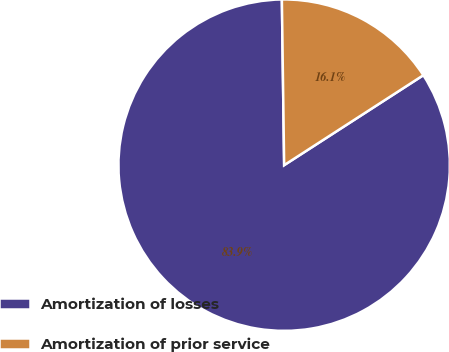Convert chart to OTSL. <chart><loc_0><loc_0><loc_500><loc_500><pie_chart><fcel>Amortization of losses<fcel>Amortization of prior service<nl><fcel>83.91%<fcel>16.09%<nl></chart> 